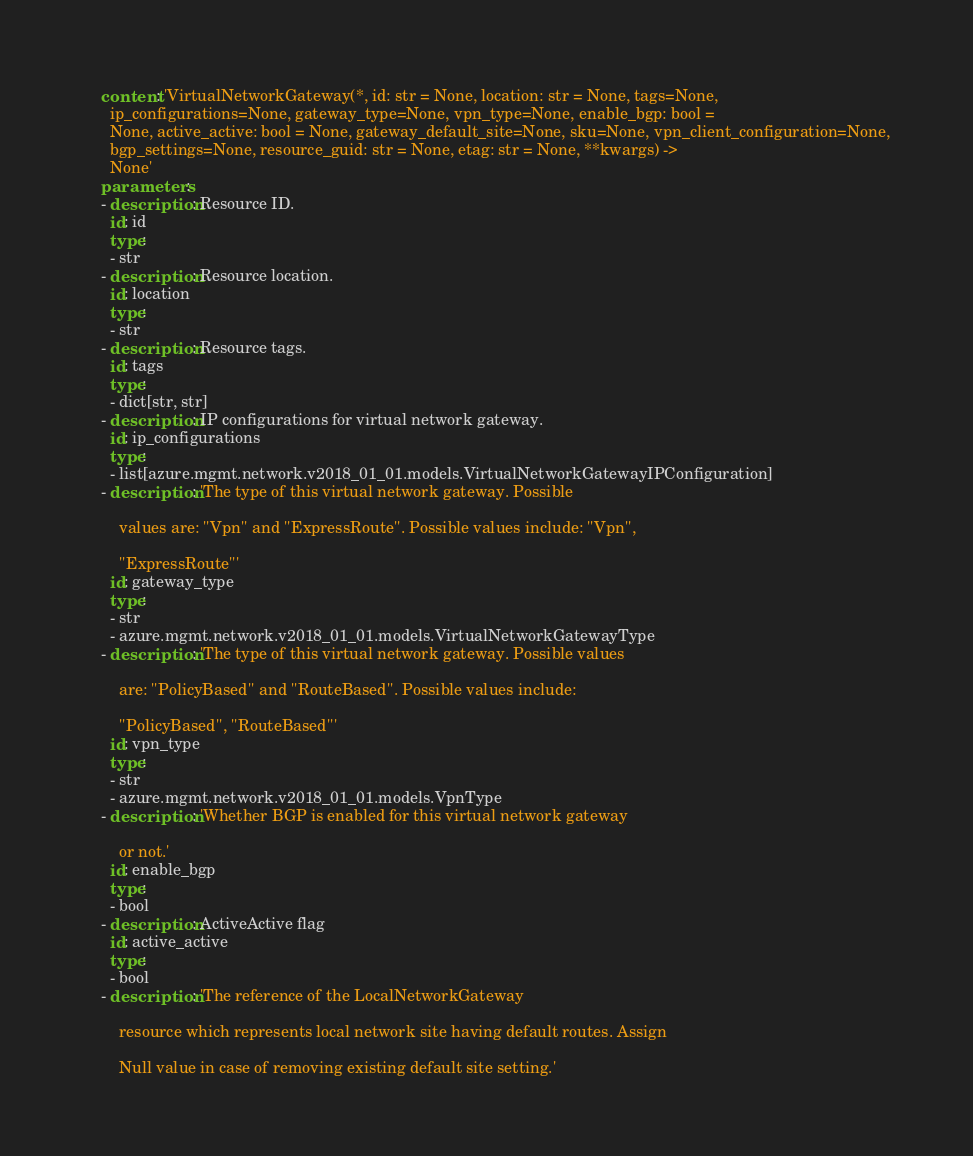<code> <loc_0><loc_0><loc_500><loc_500><_YAML_>    content: 'VirtualNetworkGateway(*, id: str = None, location: str = None, tags=None,
      ip_configurations=None, gateway_type=None, vpn_type=None, enable_bgp: bool =
      None, active_active: bool = None, gateway_default_site=None, sku=None, vpn_client_configuration=None,
      bgp_settings=None, resource_guid: str = None, etag: str = None, **kwargs) ->
      None'
    parameters:
    - description: Resource ID.
      id: id
      type:
      - str
    - description: Resource location.
      id: location
      type:
      - str
    - description: Resource tags.
      id: tags
      type:
      - dict[str, str]
    - description: IP configurations for virtual network gateway.
      id: ip_configurations
      type:
      - list[azure.mgmt.network.v2018_01_01.models.VirtualNetworkGatewayIPConfiguration]
    - description: 'The type of this virtual network gateway. Possible

        values are: ''Vpn'' and ''ExpressRoute''. Possible values include: ''Vpn'',

        ''ExpressRoute'''
      id: gateway_type
      type:
      - str
      - azure.mgmt.network.v2018_01_01.models.VirtualNetworkGatewayType
    - description: 'The type of this virtual network gateway. Possible values

        are: ''PolicyBased'' and ''RouteBased''. Possible values include:

        ''PolicyBased'', ''RouteBased'''
      id: vpn_type
      type:
      - str
      - azure.mgmt.network.v2018_01_01.models.VpnType
    - description: 'Whether BGP is enabled for this virtual network gateway

        or not.'
      id: enable_bgp
      type:
      - bool
    - description: ActiveActive flag
      id: active_active
      type:
      - bool
    - description: 'The reference of the LocalNetworkGateway

        resource which represents local network site having default routes. Assign

        Null value in case of removing existing default site setting.'</code> 